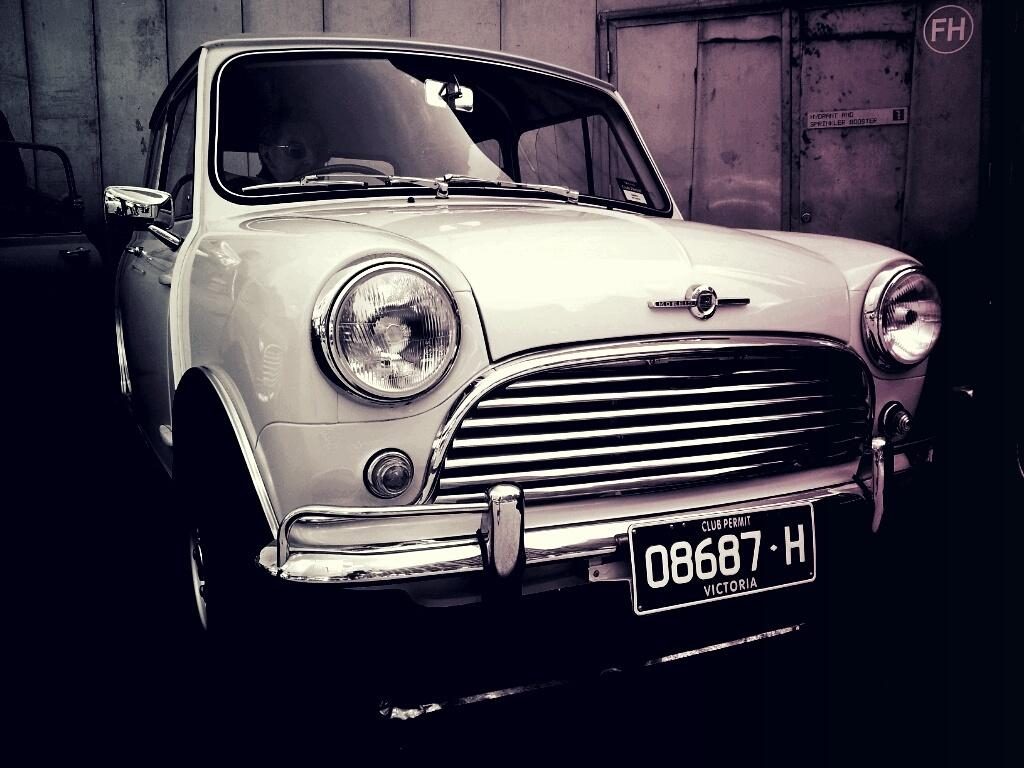<image>
Write a terse but informative summary of the picture. A Morris car with a Victoria Club Permit is parked in a garage. 